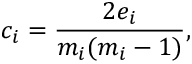Convert formula to latex. <formula><loc_0><loc_0><loc_500><loc_500>c _ { i } = \frac { 2 e _ { i } } { m _ { i } ( m _ { i } - 1 ) } ,</formula> 